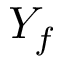Convert formula to latex. <formula><loc_0><loc_0><loc_500><loc_500>Y _ { f }</formula> 